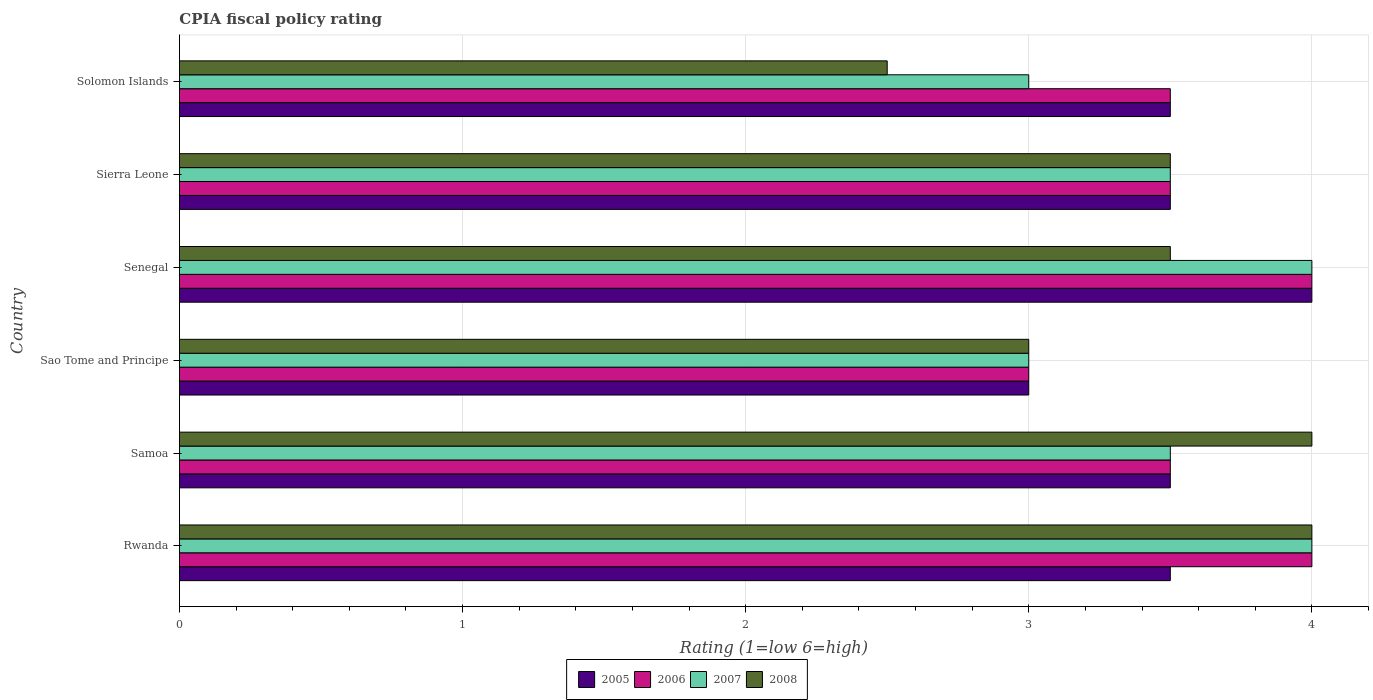How many different coloured bars are there?
Your response must be concise. 4. Are the number of bars per tick equal to the number of legend labels?
Your answer should be compact. Yes. Are the number of bars on each tick of the Y-axis equal?
Your response must be concise. Yes. How many bars are there on the 5th tick from the top?
Your answer should be very brief. 4. What is the label of the 2nd group of bars from the top?
Offer a very short reply. Sierra Leone. What is the CPIA rating in 2006 in Sao Tome and Principe?
Provide a succinct answer. 3. Across all countries, what is the minimum CPIA rating in 2007?
Make the answer very short. 3. In which country was the CPIA rating in 2005 maximum?
Keep it short and to the point. Senegal. In which country was the CPIA rating in 2007 minimum?
Provide a succinct answer. Sao Tome and Principe. What is the difference between the CPIA rating in 2005 in Rwanda and that in Senegal?
Keep it short and to the point. -0.5. What is the difference between the CPIA rating in 2008 in Senegal and the CPIA rating in 2005 in Samoa?
Provide a short and direct response. 0. What is the average CPIA rating in 2006 per country?
Keep it short and to the point. 3.58. In how many countries, is the CPIA rating in 2005 greater than 3.8 ?
Provide a succinct answer. 1. What is the ratio of the CPIA rating in 2006 in Rwanda to that in Sierra Leone?
Ensure brevity in your answer.  1.14. Is the CPIA rating in 2005 in Samoa less than that in Solomon Islands?
Provide a succinct answer. No. Is the difference between the CPIA rating in 2005 in Samoa and Solomon Islands greater than the difference between the CPIA rating in 2006 in Samoa and Solomon Islands?
Ensure brevity in your answer.  No. What is the difference between the highest and the second highest CPIA rating in 2007?
Keep it short and to the point. 0. What does the 1st bar from the top in Rwanda represents?
Offer a very short reply. 2008. What does the 2nd bar from the bottom in Rwanda represents?
Offer a terse response. 2006. How many bars are there?
Your answer should be very brief. 24. How many countries are there in the graph?
Make the answer very short. 6. What is the difference between two consecutive major ticks on the X-axis?
Your answer should be compact. 1. Are the values on the major ticks of X-axis written in scientific E-notation?
Your response must be concise. No. Does the graph contain any zero values?
Offer a very short reply. No. How many legend labels are there?
Provide a succinct answer. 4. What is the title of the graph?
Your answer should be very brief. CPIA fiscal policy rating. Does "2011" appear as one of the legend labels in the graph?
Make the answer very short. No. What is the Rating (1=low 6=high) of 2007 in Rwanda?
Offer a very short reply. 4. What is the Rating (1=low 6=high) in 2008 in Rwanda?
Offer a terse response. 4. What is the Rating (1=low 6=high) of 2006 in Samoa?
Provide a succinct answer. 3.5. What is the Rating (1=low 6=high) of 2007 in Samoa?
Offer a terse response. 3.5. What is the Rating (1=low 6=high) in 2006 in Sao Tome and Principe?
Your response must be concise. 3. What is the Rating (1=low 6=high) in 2008 in Sao Tome and Principe?
Provide a short and direct response. 3. What is the Rating (1=low 6=high) of 2006 in Senegal?
Offer a terse response. 4. What is the Rating (1=low 6=high) of 2005 in Sierra Leone?
Your response must be concise. 3.5. What is the Rating (1=low 6=high) in 2006 in Sierra Leone?
Make the answer very short. 3.5. What is the Rating (1=low 6=high) of 2008 in Sierra Leone?
Provide a short and direct response. 3.5. What is the Rating (1=low 6=high) of 2005 in Solomon Islands?
Keep it short and to the point. 3.5. What is the Rating (1=low 6=high) in 2006 in Solomon Islands?
Keep it short and to the point. 3.5. What is the Rating (1=low 6=high) in 2008 in Solomon Islands?
Provide a succinct answer. 2.5. Across all countries, what is the maximum Rating (1=low 6=high) of 2005?
Your answer should be compact. 4. Across all countries, what is the maximum Rating (1=low 6=high) in 2006?
Offer a very short reply. 4. Across all countries, what is the maximum Rating (1=low 6=high) of 2008?
Offer a terse response. 4. Across all countries, what is the minimum Rating (1=low 6=high) of 2006?
Give a very brief answer. 3. Across all countries, what is the minimum Rating (1=low 6=high) of 2007?
Provide a short and direct response. 3. What is the total Rating (1=low 6=high) in 2007 in the graph?
Your answer should be compact. 21. What is the difference between the Rating (1=low 6=high) in 2005 in Rwanda and that in Samoa?
Ensure brevity in your answer.  0. What is the difference between the Rating (1=low 6=high) in 2008 in Rwanda and that in Samoa?
Your answer should be compact. 0. What is the difference between the Rating (1=low 6=high) in 2005 in Rwanda and that in Sao Tome and Principe?
Make the answer very short. 0.5. What is the difference between the Rating (1=low 6=high) of 2007 in Rwanda and that in Sao Tome and Principe?
Give a very brief answer. 1. What is the difference between the Rating (1=low 6=high) of 2005 in Rwanda and that in Senegal?
Provide a short and direct response. -0.5. What is the difference between the Rating (1=low 6=high) in 2006 in Rwanda and that in Senegal?
Offer a very short reply. 0. What is the difference between the Rating (1=low 6=high) of 2008 in Rwanda and that in Senegal?
Your answer should be very brief. 0.5. What is the difference between the Rating (1=low 6=high) of 2005 in Rwanda and that in Sierra Leone?
Your response must be concise. 0. What is the difference between the Rating (1=low 6=high) of 2006 in Rwanda and that in Sierra Leone?
Provide a short and direct response. 0.5. What is the difference between the Rating (1=low 6=high) in 2008 in Rwanda and that in Solomon Islands?
Your answer should be very brief. 1.5. What is the difference between the Rating (1=low 6=high) of 2006 in Samoa and that in Sao Tome and Principe?
Offer a terse response. 0.5. What is the difference between the Rating (1=low 6=high) in 2007 in Samoa and that in Sao Tome and Principe?
Your answer should be compact. 0.5. What is the difference between the Rating (1=low 6=high) of 2005 in Samoa and that in Senegal?
Ensure brevity in your answer.  -0.5. What is the difference between the Rating (1=low 6=high) of 2005 in Samoa and that in Sierra Leone?
Provide a short and direct response. 0. What is the difference between the Rating (1=low 6=high) of 2007 in Samoa and that in Sierra Leone?
Give a very brief answer. 0. What is the difference between the Rating (1=low 6=high) of 2006 in Samoa and that in Solomon Islands?
Give a very brief answer. 0. What is the difference between the Rating (1=low 6=high) in 2006 in Sao Tome and Principe and that in Senegal?
Provide a short and direct response. -1. What is the difference between the Rating (1=low 6=high) of 2007 in Sao Tome and Principe and that in Senegal?
Provide a succinct answer. -1. What is the difference between the Rating (1=low 6=high) in 2007 in Sao Tome and Principe and that in Sierra Leone?
Ensure brevity in your answer.  -0.5. What is the difference between the Rating (1=low 6=high) of 2008 in Sao Tome and Principe and that in Sierra Leone?
Offer a very short reply. -0.5. What is the difference between the Rating (1=low 6=high) of 2005 in Sao Tome and Principe and that in Solomon Islands?
Give a very brief answer. -0.5. What is the difference between the Rating (1=low 6=high) in 2008 in Sao Tome and Principe and that in Solomon Islands?
Your response must be concise. 0.5. What is the difference between the Rating (1=low 6=high) in 2005 in Senegal and that in Sierra Leone?
Offer a terse response. 0.5. What is the difference between the Rating (1=low 6=high) in 2006 in Senegal and that in Sierra Leone?
Your response must be concise. 0.5. What is the difference between the Rating (1=low 6=high) of 2007 in Senegal and that in Sierra Leone?
Ensure brevity in your answer.  0.5. What is the difference between the Rating (1=low 6=high) in 2008 in Senegal and that in Sierra Leone?
Offer a very short reply. 0. What is the difference between the Rating (1=low 6=high) in 2005 in Senegal and that in Solomon Islands?
Offer a very short reply. 0.5. What is the difference between the Rating (1=low 6=high) in 2007 in Senegal and that in Solomon Islands?
Offer a very short reply. 1. What is the difference between the Rating (1=low 6=high) of 2007 in Sierra Leone and that in Solomon Islands?
Ensure brevity in your answer.  0.5. What is the difference between the Rating (1=low 6=high) in 2005 in Rwanda and the Rating (1=low 6=high) in 2006 in Samoa?
Provide a succinct answer. 0. What is the difference between the Rating (1=low 6=high) in 2005 in Rwanda and the Rating (1=low 6=high) in 2006 in Sao Tome and Principe?
Give a very brief answer. 0.5. What is the difference between the Rating (1=low 6=high) of 2005 in Rwanda and the Rating (1=low 6=high) of 2007 in Sao Tome and Principe?
Offer a terse response. 0.5. What is the difference between the Rating (1=low 6=high) in 2006 in Rwanda and the Rating (1=low 6=high) in 2007 in Sao Tome and Principe?
Offer a very short reply. 1. What is the difference between the Rating (1=low 6=high) in 2006 in Rwanda and the Rating (1=low 6=high) in 2008 in Sao Tome and Principe?
Give a very brief answer. 1. What is the difference between the Rating (1=low 6=high) in 2005 in Rwanda and the Rating (1=low 6=high) in 2007 in Senegal?
Keep it short and to the point. -0.5. What is the difference between the Rating (1=low 6=high) in 2005 in Rwanda and the Rating (1=low 6=high) in 2008 in Senegal?
Provide a succinct answer. 0. What is the difference between the Rating (1=low 6=high) of 2006 in Rwanda and the Rating (1=low 6=high) of 2008 in Senegal?
Offer a very short reply. 0.5. What is the difference between the Rating (1=low 6=high) of 2005 in Rwanda and the Rating (1=low 6=high) of 2007 in Sierra Leone?
Ensure brevity in your answer.  0. What is the difference between the Rating (1=low 6=high) of 2005 in Rwanda and the Rating (1=low 6=high) of 2008 in Sierra Leone?
Make the answer very short. 0. What is the difference between the Rating (1=low 6=high) of 2005 in Rwanda and the Rating (1=low 6=high) of 2007 in Solomon Islands?
Give a very brief answer. 0.5. What is the difference between the Rating (1=low 6=high) in 2006 in Rwanda and the Rating (1=low 6=high) in 2008 in Solomon Islands?
Your answer should be very brief. 1.5. What is the difference between the Rating (1=low 6=high) of 2005 in Samoa and the Rating (1=low 6=high) of 2006 in Sao Tome and Principe?
Make the answer very short. 0.5. What is the difference between the Rating (1=low 6=high) of 2005 in Samoa and the Rating (1=low 6=high) of 2008 in Sao Tome and Principe?
Provide a short and direct response. 0.5. What is the difference between the Rating (1=low 6=high) of 2005 in Samoa and the Rating (1=low 6=high) of 2006 in Senegal?
Offer a terse response. -0.5. What is the difference between the Rating (1=low 6=high) in 2005 in Samoa and the Rating (1=low 6=high) in 2007 in Senegal?
Provide a succinct answer. -0.5. What is the difference between the Rating (1=low 6=high) of 2005 in Samoa and the Rating (1=low 6=high) of 2008 in Senegal?
Give a very brief answer. 0. What is the difference between the Rating (1=low 6=high) in 2006 in Samoa and the Rating (1=low 6=high) in 2007 in Senegal?
Offer a very short reply. -0.5. What is the difference between the Rating (1=low 6=high) of 2006 in Samoa and the Rating (1=low 6=high) of 2008 in Sierra Leone?
Give a very brief answer. 0. What is the difference between the Rating (1=low 6=high) of 2005 in Samoa and the Rating (1=low 6=high) of 2008 in Solomon Islands?
Keep it short and to the point. 1. What is the difference between the Rating (1=low 6=high) in 2006 in Samoa and the Rating (1=low 6=high) in 2007 in Solomon Islands?
Give a very brief answer. 0.5. What is the difference between the Rating (1=low 6=high) in 2006 in Samoa and the Rating (1=low 6=high) in 2008 in Solomon Islands?
Offer a terse response. 1. What is the difference between the Rating (1=low 6=high) of 2007 in Samoa and the Rating (1=low 6=high) of 2008 in Solomon Islands?
Make the answer very short. 1. What is the difference between the Rating (1=low 6=high) in 2005 in Sao Tome and Principe and the Rating (1=low 6=high) in 2008 in Senegal?
Make the answer very short. -0.5. What is the difference between the Rating (1=low 6=high) in 2006 in Sao Tome and Principe and the Rating (1=low 6=high) in 2007 in Senegal?
Give a very brief answer. -1. What is the difference between the Rating (1=low 6=high) in 2006 in Sao Tome and Principe and the Rating (1=low 6=high) in 2008 in Senegal?
Offer a terse response. -0.5. What is the difference between the Rating (1=low 6=high) of 2007 in Sao Tome and Principe and the Rating (1=low 6=high) of 2008 in Senegal?
Your response must be concise. -0.5. What is the difference between the Rating (1=low 6=high) in 2007 in Sao Tome and Principe and the Rating (1=low 6=high) in 2008 in Sierra Leone?
Offer a terse response. -0.5. What is the difference between the Rating (1=low 6=high) of 2005 in Sao Tome and Principe and the Rating (1=low 6=high) of 2007 in Solomon Islands?
Make the answer very short. 0. What is the difference between the Rating (1=low 6=high) of 2005 in Sao Tome and Principe and the Rating (1=low 6=high) of 2008 in Solomon Islands?
Provide a short and direct response. 0.5. What is the difference between the Rating (1=low 6=high) in 2006 in Sao Tome and Principe and the Rating (1=low 6=high) in 2007 in Solomon Islands?
Offer a very short reply. 0. What is the difference between the Rating (1=low 6=high) in 2007 in Sao Tome and Principe and the Rating (1=low 6=high) in 2008 in Solomon Islands?
Offer a very short reply. 0.5. What is the difference between the Rating (1=low 6=high) of 2005 in Senegal and the Rating (1=low 6=high) of 2006 in Sierra Leone?
Ensure brevity in your answer.  0.5. What is the difference between the Rating (1=low 6=high) in 2005 in Senegal and the Rating (1=low 6=high) in 2007 in Sierra Leone?
Give a very brief answer. 0.5. What is the difference between the Rating (1=low 6=high) in 2005 in Senegal and the Rating (1=low 6=high) in 2008 in Sierra Leone?
Provide a succinct answer. 0.5. What is the difference between the Rating (1=low 6=high) of 2006 in Senegal and the Rating (1=low 6=high) of 2007 in Sierra Leone?
Keep it short and to the point. 0.5. What is the difference between the Rating (1=low 6=high) of 2006 in Senegal and the Rating (1=low 6=high) of 2008 in Sierra Leone?
Your answer should be compact. 0.5. What is the difference between the Rating (1=low 6=high) of 2007 in Senegal and the Rating (1=low 6=high) of 2008 in Sierra Leone?
Provide a short and direct response. 0.5. What is the difference between the Rating (1=low 6=high) in 2005 in Senegal and the Rating (1=low 6=high) in 2006 in Solomon Islands?
Your answer should be very brief. 0.5. What is the difference between the Rating (1=low 6=high) of 2006 in Senegal and the Rating (1=low 6=high) of 2008 in Solomon Islands?
Make the answer very short. 1.5. What is the difference between the Rating (1=low 6=high) of 2005 in Sierra Leone and the Rating (1=low 6=high) of 2006 in Solomon Islands?
Provide a succinct answer. 0. What is the difference between the Rating (1=low 6=high) of 2005 in Sierra Leone and the Rating (1=low 6=high) of 2007 in Solomon Islands?
Ensure brevity in your answer.  0.5. What is the difference between the Rating (1=low 6=high) of 2005 in Sierra Leone and the Rating (1=low 6=high) of 2008 in Solomon Islands?
Give a very brief answer. 1. What is the difference between the Rating (1=low 6=high) of 2006 in Sierra Leone and the Rating (1=low 6=high) of 2007 in Solomon Islands?
Offer a very short reply. 0.5. What is the average Rating (1=low 6=high) in 2005 per country?
Ensure brevity in your answer.  3.5. What is the average Rating (1=low 6=high) in 2006 per country?
Your answer should be very brief. 3.58. What is the average Rating (1=low 6=high) in 2008 per country?
Your answer should be very brief. 3.42. What is the difference between the Rating (1=low 6=high) in 2005 and Rating (1=low 6=high) in 2006 in Rwanda?
Provide a succinct answer. -0.5. What is the difference between the Rating (1=low 6=high) of 2005 and Rating (1=low 6=high) of 2007 in Rwanda?
Provide a short and direct response. -0.5. What is the difference between the Rating (1=low 6=high) of 2005 and Rating (1=low 6=high) of 2008 in Rwanda?
Your answer should be compact. -0.5. What is the difference between the Rating (1=low 6=high) of 2006 and Rating (1=low 6=high) of 2008 in Rwanda?
Your response must be concise. 0. What is the difference between the Rating (1=low 6=high) of 2006 and Rating (1=low 6=high) of 2007 in Samoa?
Keep it short and to the point. 0. What is the difference between the Rating (1=low 6=high) of 2005 and Rating (1=low 6=high) of 2006 in Sao Tome and Principe?
Give a very brief answer. 0. What is the difference between the Rating (1=low 6=high) of 2005 and Rating (1=low 6=high) of 2007 in Sao Tome and Principe?
Your answer should be very brief. 0. What is the difference between the Rating (1=low 6=high) in 2005 and Rating (1=low 6=high) in 2008 in Sao Tome and Principe?
Provide a short and direct response. 0. What is the difference between the Rating (1=low 6=high) in 2006 and Rating (1=low 6=high) in 2007 in Sao Tome and Principe?
Offer a very short reply. 0. What is the difference between the Rating (1=low 6=high) in 2005 and Rating (1=low 6=high) in 2007 in Senegal?
Keep it short and to the point. 0. What is the difference between the Rating (1=low 6=high) in 2005 and Rating (1=low 6=high) in 2006 in Sierra Leone?
Give a very brief answer. 0. What is the difference between the Rating (1=low 6=high) of 2005 and Rating (1=low 6=high) of 2006 in Solomon Islands?
Give a very brief answer. 0. What is the difference between the Rating (1=low 6=high) of 2005 and Rating (1=low 6=high) of 2008 in Solomon Islands?
Ensure brevity in your answer.  1. What is the ratio of the Rating (1=low 6=high) in 2007 in Rwanda to that in Samoa?
Make the answer very short. 1.14. What is the ratio of the Rating (1=low 6=high) in 2008 in Rwanda to that in Samoa?
Ensure brevity in your answer.  1. What is the ratio of the Rating (1=low 6=high) in 2005 in Rwanda to that in Sao Tome and Principe?
Your answer should be very brief. 1.17. What is the ratio of the Rating (1=low 6=high) in 2005 in Rwanda to that in Senegal?
Your answer should be very brief. 0.88. What is the ratio of the Rating (1=low 6=high) of 2006 in Rwanda to that in Senegal?
Provide a short and direct response. 1. What is the ratio of the Rating (1=low 6=high) of 2008 in Rwanda to that in Senegal?
Your answer should be compact. 1.14. What is the ratio of the Rating (1=low 6=high) of 2005 in Rwanda to that in Sierra Leone?
Offer a very short reply. 1. What is the ratio of the Rating (1=low 6=high) of 2007 in Rwanda to that in Sierra Leone?
Your response must be concise. 1.14. What is the ratio of the Rating (1=low 6=high) in 2008 in Rwanda to that in Sierra Leone?
Ensure brevity in your answer.  1.14. What is the ratio of the Rating (1=low 6=high) of 2006 in Rwanda to that in Solomon Islands?
Your answer should be compact. 1.14. What is the ratio of the Rating (1=low 6=high) of 2007 in Rwanda to that in Solomon Islands?
Make the answer very short. 1.33. What is the ratio of the Rating (1=low 6=high) in 2008 in Rwanda to that in Solomon Islands?
Your response must be concise. 1.6. What is the ratio of the Rating (1=low 6=high) of 2005 in Samoa to that in Sao Tome and Principe?
Provide a short and direct response. 1.17. What is the ratio of the Rating (1=low 6=high) in 2006 in Samoa to that in Sao Tome and Principe?
Ensure brevity in your answer.  1.17. What is the ratio of the Rating (1=low 6=high) in 2007 in Samoa to that in Sao Tome and Principe?
Your answer should be very brief. 1.17. What is the ratio of the Rating (1=low 6=high) in 2006 in Samoa to that in Senegal?
Provide a short and direct response. 0.88. What is the ratio of the Rating (1=low 6=high) of 2007 in Samoa to that in Senegal?
Ensure brevity in your answer.  0.88. What is the ratio of the Rating (1=low 6=high) in 2008 in Samoa to that in Senegal?
Your response must be concise. 1.14. What is the ratio of the Rating (1=low 6=high) of 2006 in Samoa to that in Sierra Leone?
Your answer should be very brief. 1. What is the ratio of the Rating (1=low 6=high) of 2007 in Samoa to that in Sierra Leone?
Your answer should be very brief. 1. What is the ratio of the Rating (1=low 6=high) in 2006 in Samoa to that in Solomon Islands?
Ensure brevity in your answer.  1. What is the ratio of the Rating (1=low 6=high) of 2007 in Samoa to that in Solomon Islands?
Give a very brief answer. 1.17. What is the ratio of the Rating (1=low 6=high) of 2008 in Samoa to that in Solomon Islands?
Your answer should be very brief. 1.6. What is the ratio of the Rating (1=low 6=high) of 2007 in Sao Tome and Principe to that in Senegal?
Provide a short and direct response. 0.75. What is the ratio of the Rating (1=low 6=high) in 2008 in Sao Tome and Principe to that in Senegal?
Your answer should be compact. 0.86. What is the ratio of the Rating (1=low 6=high) in 2007 in Sao Tome and Principe to that in Sierra Leone?
Keep it short and to the point. 0.86. What is the ratio of the Rating (1=low 6=high) in 2008 in Sao Tome and Principe to that in Sierra Leone?
Ensure brevity in your answer.  0.86. What is the ratio of the Rating (1=low 6=high) of 2005 in Sao Tome and Principe to that in Solomon Islands?
Ensure brevity in your answer.  0.86. What is the ratio of the Rating (1=low 6=high) in 2008 in Sao Tome and Principe to that in Solomon Islands?
Keep it short and to the point. 1.2. What is the ratio of the Rating (1=low 6=high) of 2007 in Senegal to that in Sierra Leone?
Offer a very short reply. 1.14. What is the ratio of the Rating (1=low 6=high) in 2008 in Senegal to that in Sierra Leone?
Your answer should be compact. 1. What is the ratio of the Rating (1=low 6=high) of 2007 in Senegal to that in Solomon Islands?
Ensure brevity in your answer.  1.33. What is the ratio of the Rating (1=low 6=high) of 2008 in Senegal to that in Solomon Islands?
Your response must be concise. 1.4. What is the ratio of the Rating (1=low 6=high) in 2005 in Sierra Leone to that in Solomon Islands?
Ensure brevity in your answer.  1. What is the ratio of the Rating (1=low 6=high) of 2007 in Sierra Leone to that in Solomon Islands?
Your answer should be very brief. 1.17. What is the ratio of the Rating (1=low 6=high) in 2008 in Sierra Leone to that in Solomon Islands?
Offer a very short reply. 1.4. What is the difference between the highest and the second highest Rating (1=low 6=high) in 2006?
Provide a succinct answer. 0. What is the difference between the highest and the second highest Rating (1=low 6=high) in 2007?
Your answer should be very brief. 0. What is the difference between the highest and the lowest Rating (1=low 6=high) of 2008?
Your answer should be very brief. 1.5. 